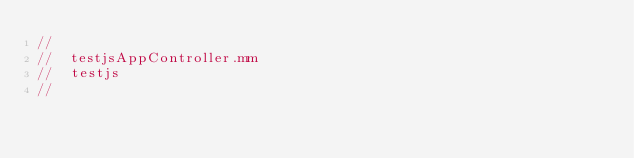Convert code to text. <code><loc_0><loc_0><loc_500><loc_500><_ObjectiveC_>//
//  testjsAppController.mm
//  testjs
//</code> 